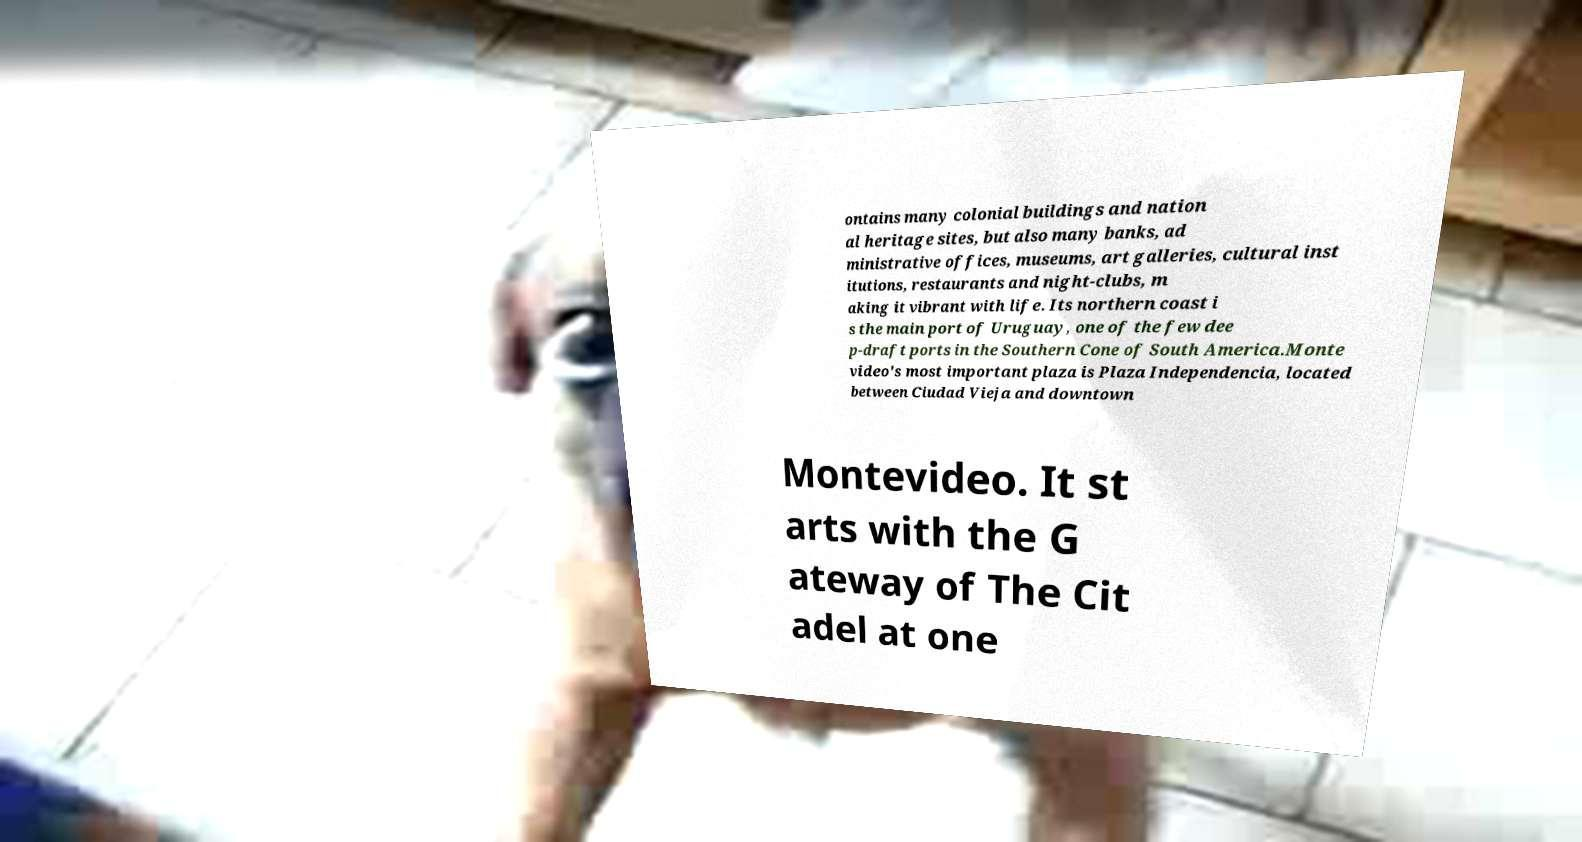Please read and relay the text visible in this image. What does it say? ontains many colonial buildings and nation al heritage sites, but also many banks, ad ministrative offices, museums, art galleries, cultural inst itutions, restaurants and night-clubs, m aking it vibrant with life. Its northern coast i s the main port of Uruguay, one of the few dee p-draft ports in the Southern Cone of South America.Monte video's most important plaza is Plaza Independencia, located between Ciudad Vieja and downtown Montevideo. It st arts with the G ateway of The Cit adel at one 